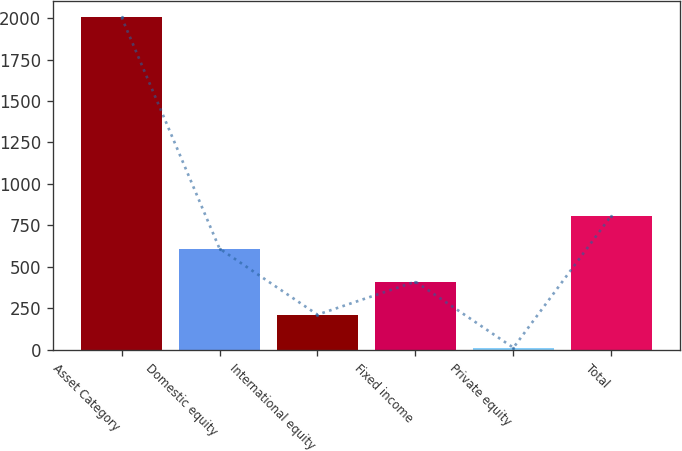Convert chart. <chart><loc_0><loc_0><loc_500><loc_500><bar_chart><fcel>Asset Category<fcel>Domestic equity<fcel>International equity<fcel>Fixed income<fcel>Private equity<fcel>Total<nl><fcel>2005<fcel>610.6<fcel>212.2<fcel>411.4<fcel>13<fcel>809.8<nl></chart> 